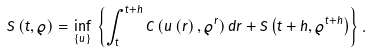Convert formula to latex. <formula><loc_0><loc_0><loc_500><loc_500>S \left ( t , \varrho \right ) = \inf _ { \left \{ u \right \} } \, \left \{ \int _ { t } ^ { t + h } C \left ( u \left ( r \right ) , \varrho ^ { r } \right ) d r + S \left ( t + h , \varrho ^ { t + h } \right ) \right \} .</formula> 